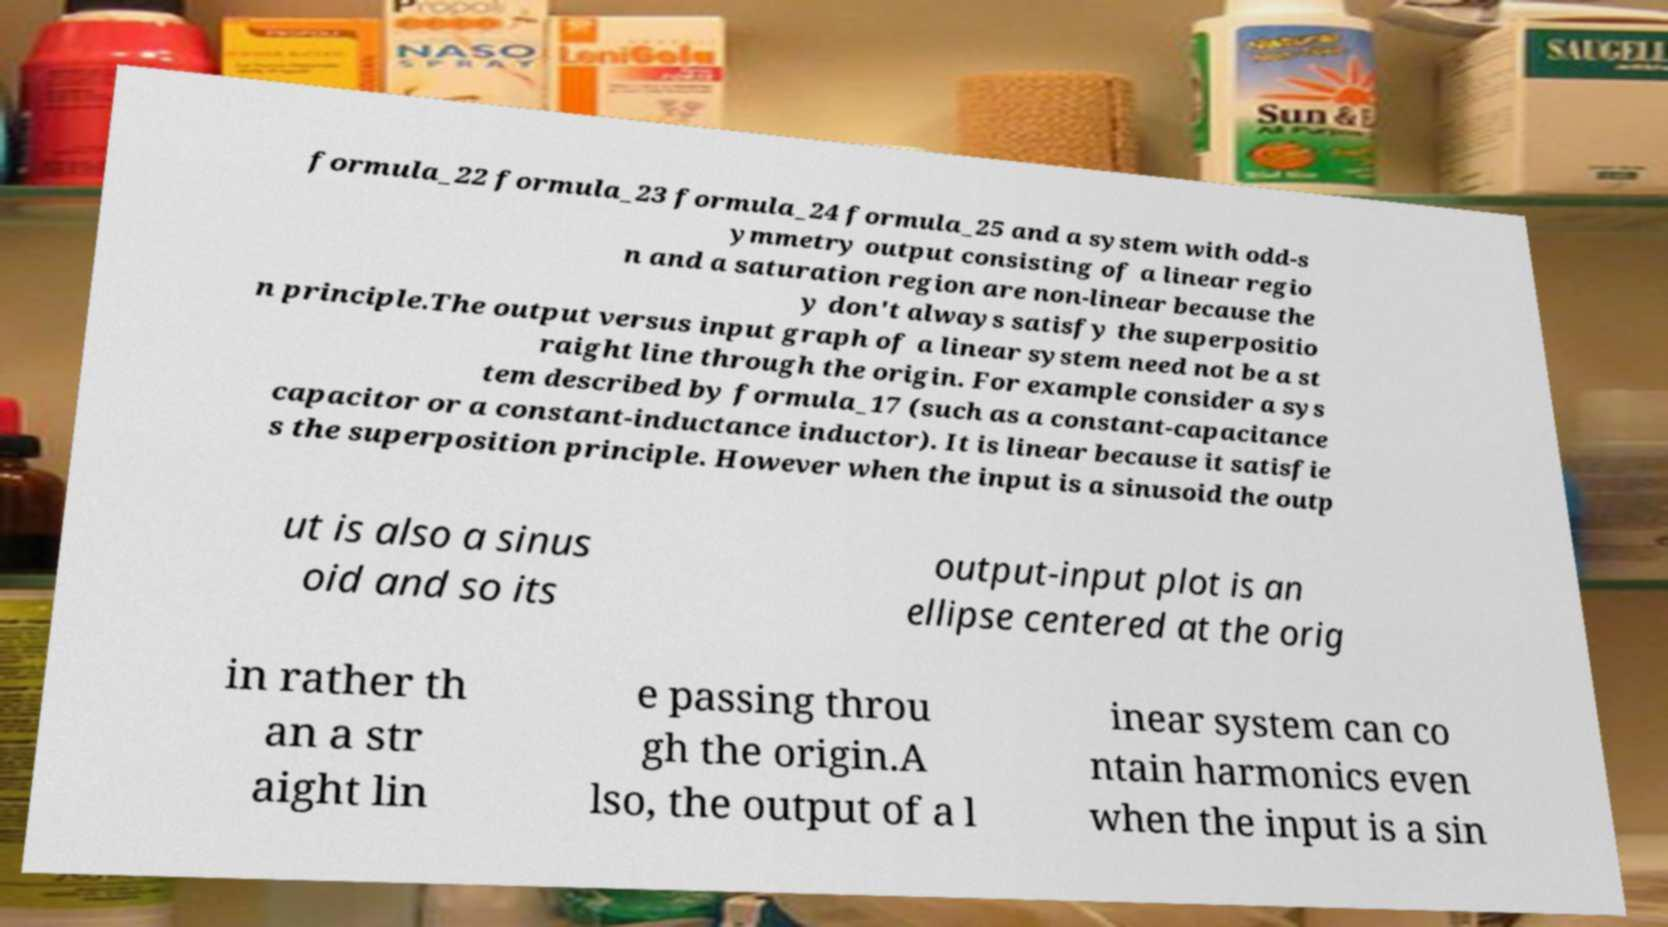Please identify and transcribe the text found in this image. formula_22 formula_23 formula_24 formula_25 and a system with odd-s ymmetry output consisting of a linear regio n and a saturation region are non-linear because the y don't always satisfy the superpositio n principle.The output versus input graph of a linear system need not be a st raight line through the origin. For example consider a sys tem described by formula_17 (such as a constant-capacitance capacitor or a constant-inductance inductor). It is linear because it satisfie s the superposition principle. However when the input is a sinusoid the outp ut is also a sinus oid and so its output-input plot is an ellipse centered at the orig in rather th an a str aight lin e passing throu gh the origin.A lso, the output of a l inear system can co ntain harmonics even when the input is a sin 